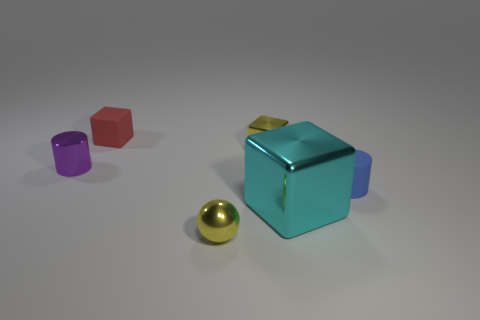Do the small purple cylinder and the small red block have the same material?
Provide a succinct answer. No. How many big blocks are on the left side of the tiny cylinder that is left of the blue rubber cylinder?
Ensure brevity in your answer.  0. What number of cyan things are small cylinders or large cubes?
Provide a short and direct response. 1. The small matte thing left of the tiny yellow shiny thing that is behind the small metal thing that is on the left side of the tiny matte block is what shape?
Offer a very short reply. Cube. What is the color of the shiny block that is the same size as the yellow metal sphere?
Make the answer very short. Yellow. What number of tiny red matte objects have the same shape as the big object?
Ensure brevity in your answer.  1. Does the matte cylinder have the same size as the block in front of the blue matte thing?
Give a very brief answer. No. There is a small yellow object that is to the left of the yellow thing behind the cyan metallic block; what is its shape?
Offer a very short reply. Sphere. Is the number of tiny cubes in front of the small red rubber cube less than the number of tiny matte things?
Your answer should be compact. Yes. There is a object that is the same color as the ball; what shape is it?
Offer a very short reply. Cube. 